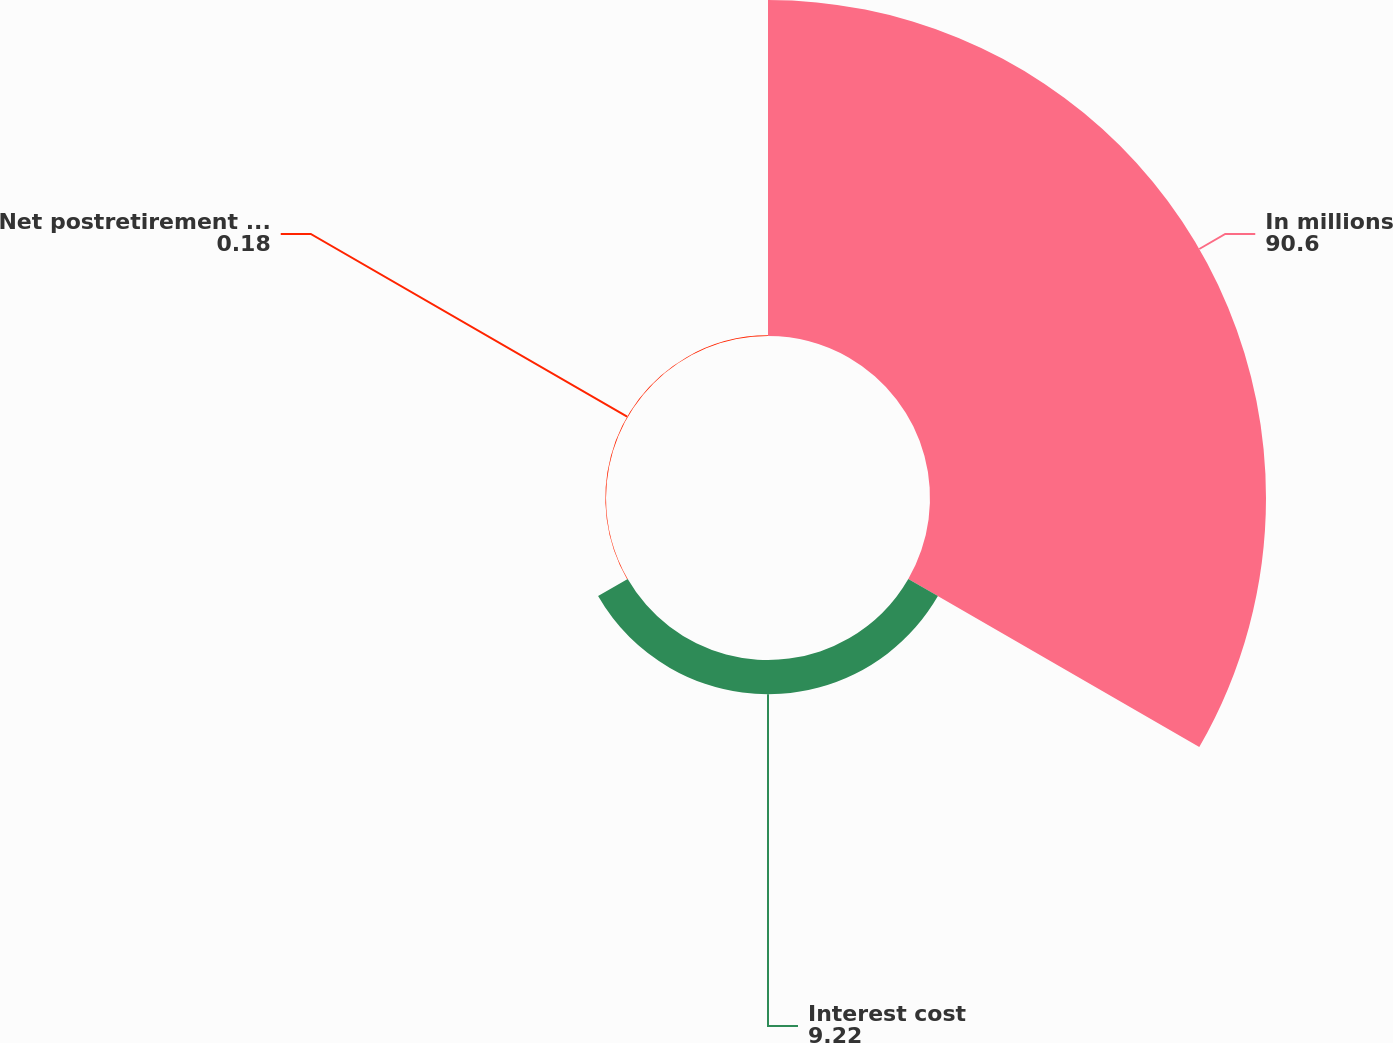<chart> <loc_0><loc_0><loc_500><loc_500><pie_chart><fcel>In millions<fcel>Interest cost<fcel>Net postretirement (benefit)<nl><fcel>90.6%<fcel>9.22%<fcel>0.18%<nl></chart> 